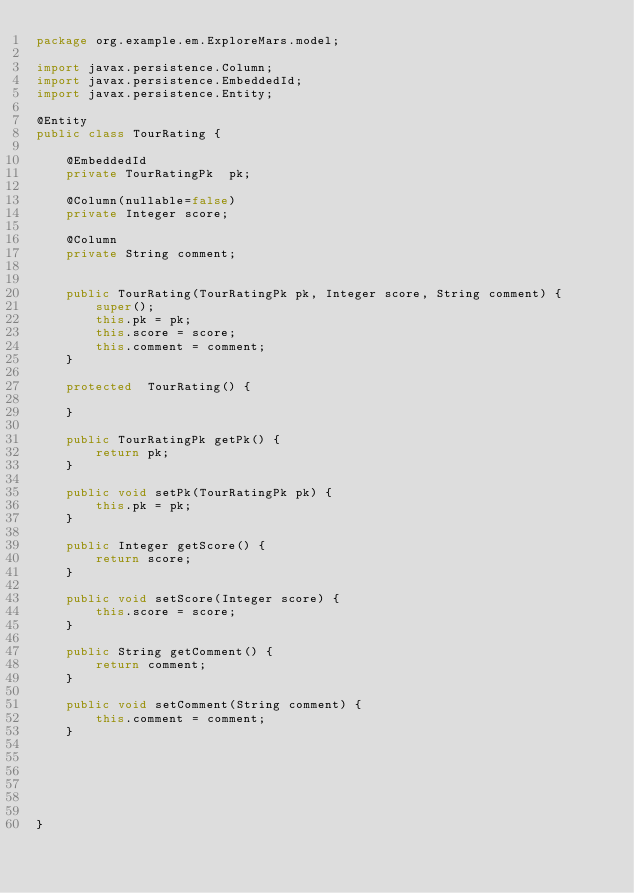<code> <loc_0><loc_0><loc_500><loc_500><_Java_>package org.example.em.ExploreMars.model;

import javax.persistence.Column;
import javax.persistence.EmbeddedId;
import javax.persistence.Entity;

@Entity
public class TourRating {
	
	@EmbeddedId
	private TourRatingPk  pk;
	
	@Column(nullable=false)
	private Integer score;
	
	@Column
	private String comment;
	

	public TourRating(TourRatingPk pk, Integer score, String comment) {
		super();
		this.pk = pk;
		this.score = score;
		this.comment = comment;
	}

	protected  TourRating() {
		
	}

	public TourRatingPk getPk() {
		return pk;
	}

	public void setPk(TourRatingPk pk) {
		this.pk = pk;
	}

	public Integer getScore() {
		return score;
	}

	public void setScore(Integer score) {
		this.score = score;
	}

	public String getComment() {
		return comment;
	}

	public void setComment(String comment) {
		this.comment = comment;
	}
	

	
	
	

}
</code> 